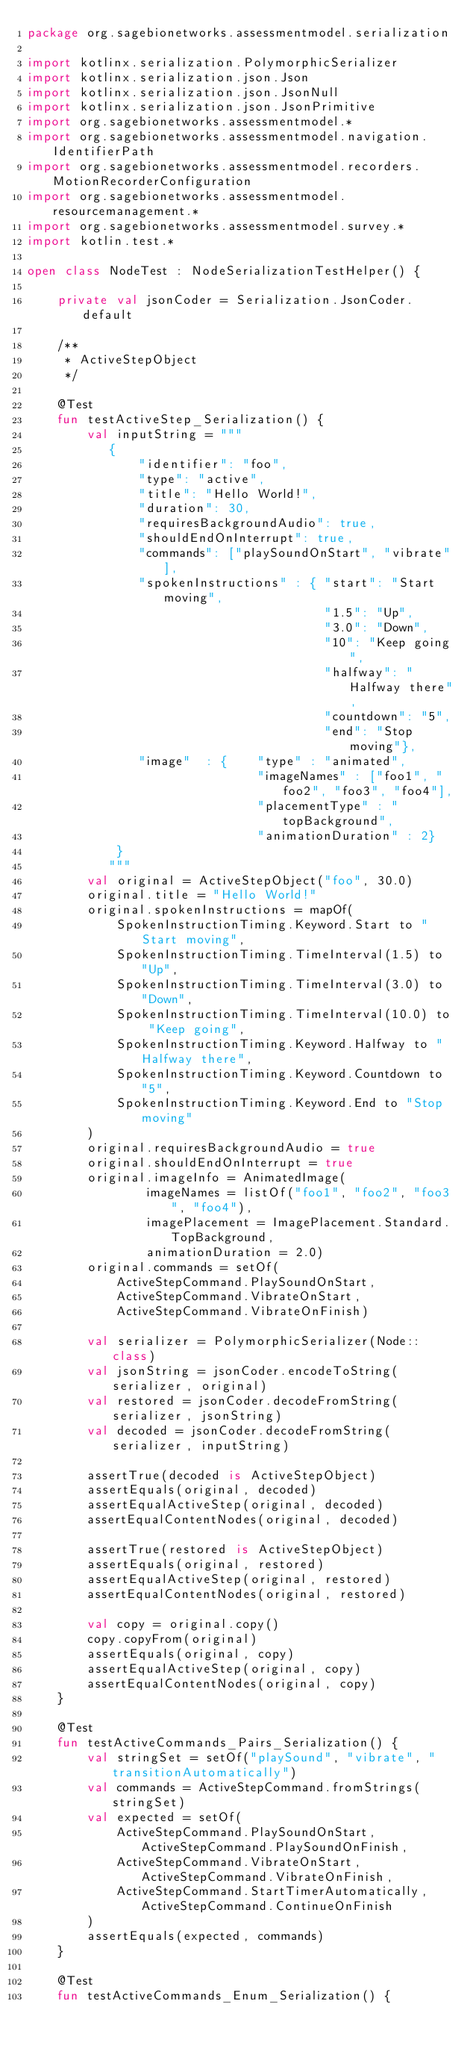Convert code to text. <code><loc_0><loc_0><loc_500><loc_500><_Kotlin_>package org.sagebionetworks.assessmentmodel.serialization

import kotlinx.serialization.PolymorphicSerializer
import kotlinx.serialization.json.Json
import kotlinx.serialization.json.JsonNull
import kotlinx.serialization.json.JsonPrimitive
import org.sagebionetworks.assessmentmodel.*
import org.sagebionetworks.assessmentmodel.navigation.IdentifierPath
import org.sagebionetworks.assessmentmodel.recorders.MotionRecorderConfiguration
import org.sagebionetworks.assessmentmodel.resourcemanagement.*
import org.sagebionetworks.assessmentmodel.survey.*
import kotlin.test.*

open class NodeTest : NodeSerializationTestHelper() {

    private val jsonCoder = Serialization.JsonCoder.default

    /**
     * ActiveStepObject
     */

    @Test
    fun testActiveStep_Serialization() {
        val inputString = """
           {
               "identifier": "foo",
               "type": "active",
               "title": "Hello World!",
               "duration": 30,
               "requiresBackgroundAudio": true,
               "shouldEndOnInterrupt": true,
               "commands": ["playSoundOnStart", "vibrate"],
               "spokenInstructions" : { "start": "Start moving",
                                        "1.5": "Up",
                                        "3.0": "Down",
                                        "10": "Keep going",
                                        "halfway": "Halfway there",
                                        "countdown": "5",
                                        "end": "Stop moving"},
               "image"  : {    "type" : "animated",
                               "imageNames" : ["foo1", "foo2", "foo3", "foo4"],
                               "placementType" : "topBackground",
                               "animationDuration" : 2}
            }
           """
        val original = ActiveStepObject("foo", 30.0)
        original.title = "Hello World!"
        original.spokenInstructions = mapOf(
            SpokenInstructionTiming.Keyword.Start to "Start moving",
            SpokenInstructionTiming.TimeInterval(1.5) to "Up",
            SpokenInstructionTiming.TimeInterval(3.0) to "Down",
            SpokenInstructionTiming.TimeInterval(10.0) to "Keep going",
            SpokenInstructionTiming.Keyword.Halfway to "Halfway there",
            SpokenInstructionTiming.Keyword.Countdown to "5",
            SpokenInstructionTiming.Keyword.End to "Stop moving"
        )
        original.requiresBackgroundAudio = true
        original.shouldEndOnInterrupt = true
        original.imageInfo = AnimatedImage(
                imageNames = listOf("foo1", "foo2", "foo3", "foo4"),
                imagePlacement = ImagePlacement.Standard.TopBackground,
                animationDuration = 2.0)
        original.commands = setOf(
            ActiveStepCommand.PlaySoundOnStart,
            ActiveStepCommand.VibrateOnStart,
            ActiveStepCommand.VibrateOnFinish)

        val serializer = PolymorphicSerializer(Node::class)
        val jsonString = jsonCoder.encodeToString(serializer, original)
        val restored = jsonCoder.decodeFromString(serializer, jsonString)
        val decoded = jsonCoder.decodeFromString(serializer, inputString)

        assertTrue(decoded is ActiveStepObject)
        assertEquals(original, decoded)
        assertEqualActiveStep(original, decoded)
        assertEqualContentNodes(original, decoded)

        assertTrue(restored is ActiveStepObject)
        assertEquals(original, restored)
        assertEqualActiveStep(original, restored)
        assertEqualContentNodes(original, restored)

        val copy = original.copy()
        copy.copyFrom(original)
        assertEquals(original, copy)
        assertEqualActiveStep(original, copy)
        assertEqualContentNodes(original, copy)
    }

    @Test
    fun testActiveCommands_Pairs_Serialization() {
        val stringSet = setOf("playSound", "vibrate", "transitionAutomatically")
        val commands = ActiveStepCommand.fromStrings(stringSet)
        val expected = setOf(
            ActiveStepCommand.PlaySoundOnStart, ActiveStepCommand.PlaySoundOnFinish,
            ActiveStepCommand.VibrateOnStart, ActiveStepCommand.VibrateOnFinish,
            ActiveStepCommand.StartTimerAutomatically, ActiveStepCommand.ContinueOnFinish
        )
        assertEquals(expected, commands)
    }

    @Test
    fun testActiveCommands_Enum_Serialization() {</code> 